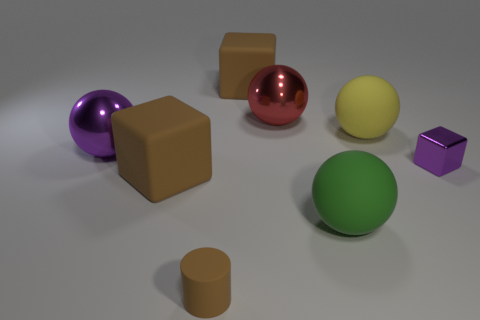Can you describe the different shapes and materials of objects in this image? Certainly! The image includes a variety of geometric shapes. There's a purple sphere with a reflective surface, likely metallic. Next, there's a brown cube and a red sphere, also with metallic finishes. A matte yellow sphere and a green sphere suggest a plastic or rubber material. The brown cylinder on the left might be made of cardboard or plastic, and the small purple cube also appears to have a matte finish. 